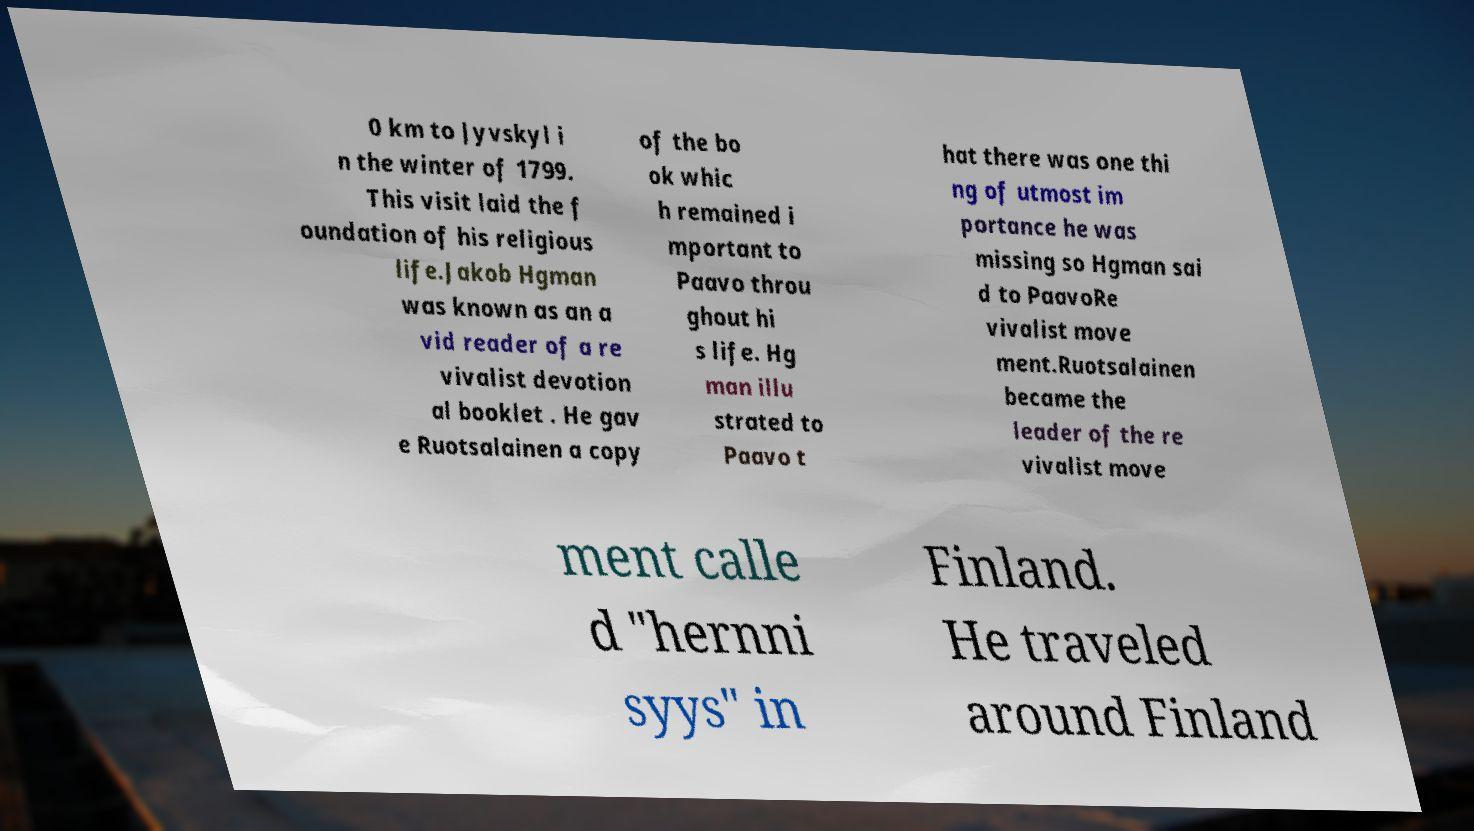Could you extract and type out the text from this image? 0 km to Jyvskyl i n the winter of 1799. This visit laid the f oundation of his religious life.Jakob Hgman was known as an a vid reader of a re vivalist devotion al booklet . He gav e Ruotsalainen a copy of the bo ok whic h remained i mportant to Paavo throu ghout hi s life. Hg man illu strated to Paavo t hat there was one thi ng of utmost im portance he was missing so Hgman sai d to PaavoRe vivalist move ment.Ruotsalainen became the leader of the re vivalist move ment calle d "hernni syys" in Finland. He traveled around Finland 